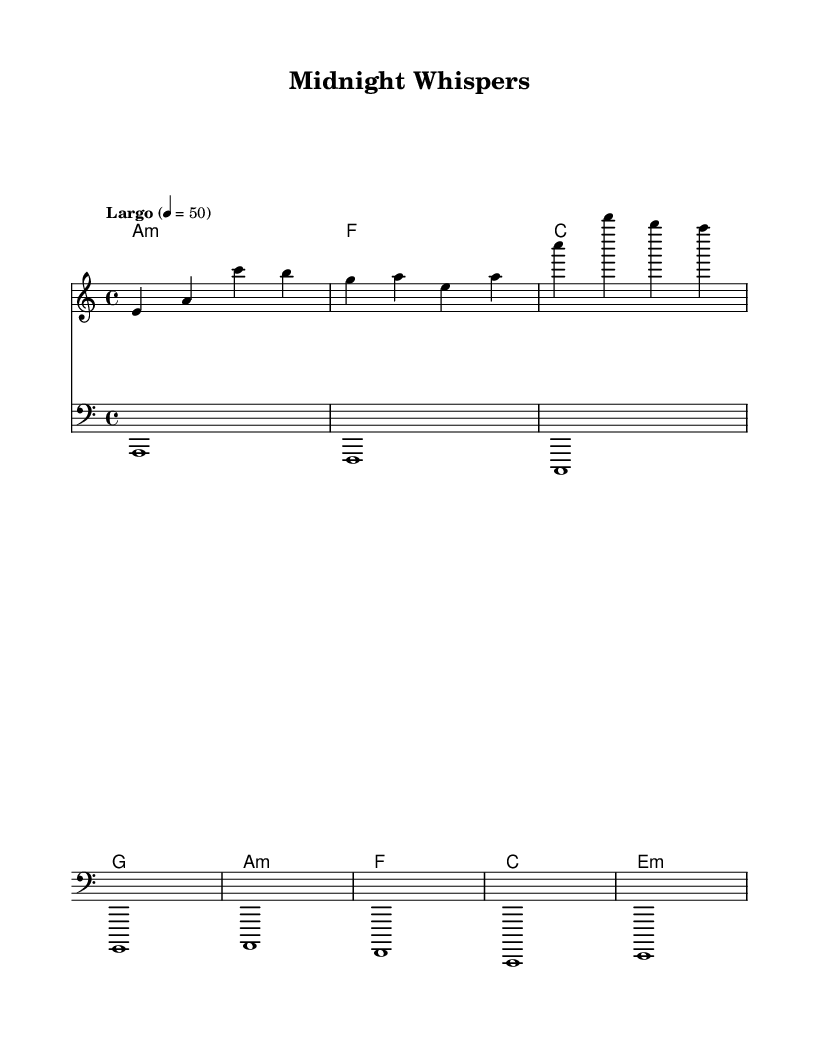What is the key signature of this music? The key signature shows two flats, indicating that the piece is in A minor. In a conventional key signature chart, A minor is relative to C major, which has no sharps or flats.
Answer: A minor What is the time signature of this music? The time signature is indicated at the beginning of the score, showing a 4/4 time. This means there are four beats in each measure, and a quarter note receives one beat.
Answer: 4/4 What is the tempo marking of this piece? The tempo marking is specified as "Largo" with a metronome marking of 50, which indicates a slow and broad tempo suitable for the emotional context of the piece.
Answer: Largo, 50 How many measures are in the melody? By counting the measures in the melody part, we see there are four measures. Each measure is separated by a vertical line, consistently dividing the music.
Answer: Four What kind of chord progression is used in the harmonies? The harmonies employ a simple four-chord progression: A minor, F major, C major, and G major, creating a classic sound often found in romantic music. This progression supports the overall emotional weight of the melody.
Answer: A minor, F, C, G What is the rhythmic feel of the bass line? The bass line plays whole notes (holding each note for the duration of a whole measure), contributing to the calm, steady foundation typical of ambient electronic romantic textures.
Answer: Whole notes What mood does this music evoke based on its structure? The combination of a slow tempo, minor key signature, and rich harmonies creates a romantic and introspective mood, ideal for late-night editing sessions in a podcast focusing on emotional themes.
Answer: Romantic and introspective 